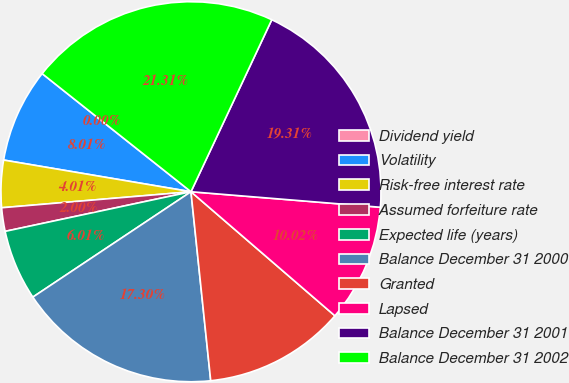<chart> <loc_0><loc_0><loc_500><loc_500><pie_chart><fcel>Dividend yield<fcel>Volatility<fcel>Risk-free interest rate<fcel>Assumed forfeiture rate<fcel>Expected life (years)<fcel>Balance December 31 2000<fcel>Granted<fcel>Lapsed<fcel>Balance December 31 2001<fcel>Balance December 31 2002<nl><fcel>0.0%<fcel>8.01%<fcel>4.01%<fcel>2.0%<fcel>6.01%<fcel>17.3%<fcel>12.02%<fcel>10.02%<fcel>19.31%<fcel>21.31%<nl></chart> 